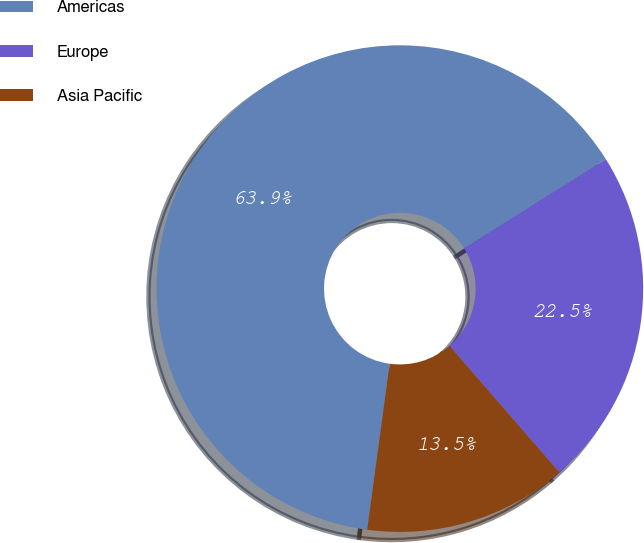Convert chart to OTSL. <chart><loc_0><loc_0><loc_500><loc_500><pie_chart><fcel>Americas<fcel>Europe<fcel>Asia Pacific<nl><fcel>63.92%<fcel>22.55%<fcel>13.53%<nl></chart> 